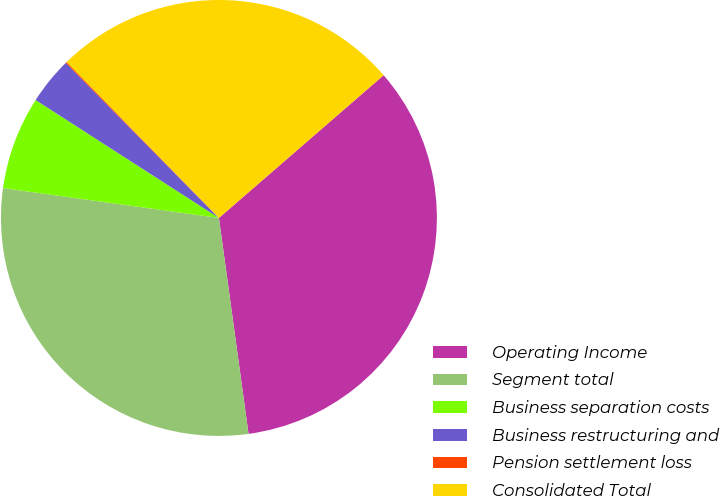Convert chart. <chart><loc_0><loc_0><loc_500><loc_500><pie_chart><fcel>Operating Income<fcel>Segment total<fcel>Business separation costs<fcel>Business restructuring and<fcel>Pension settlement loss<fcel>Consolidated Total<nl><fcel>34.2%<fcel>29.36%<fcel>6.91%<fcel>3.5%<fcel>0.09%<fcel>25.95%<nl></chart> 